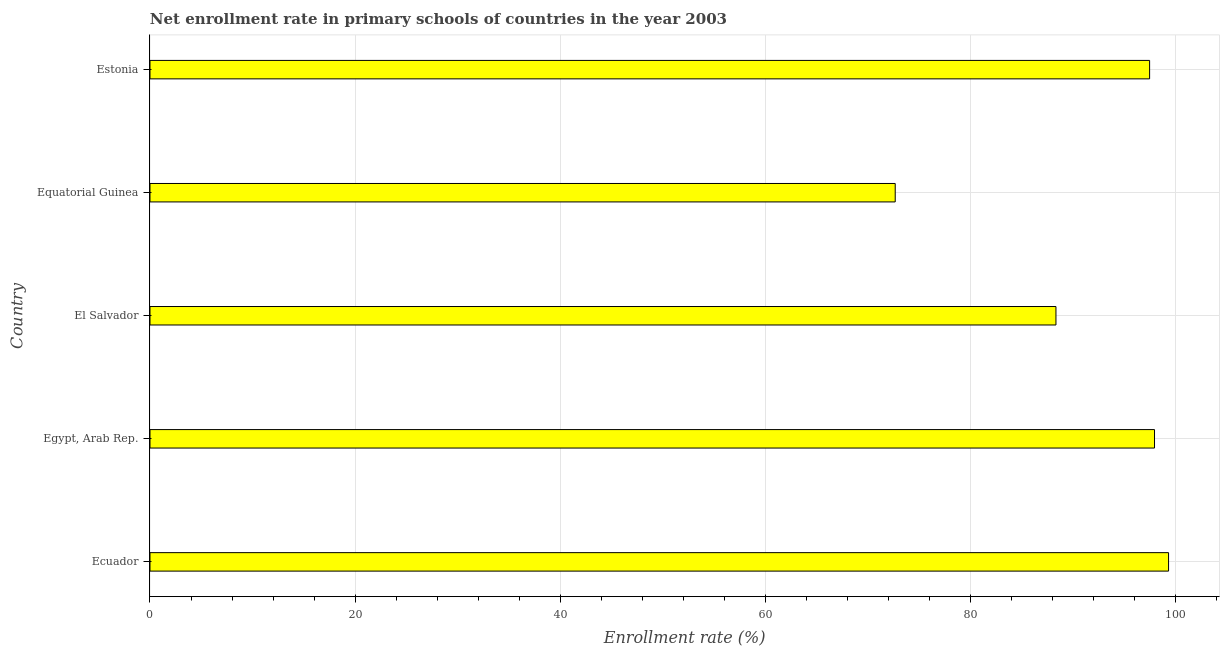Does the graph contain any zero values?
Provide a succinct answer. No. Does the graph contain grids?
Your response must be concise. Yes. What is the title of the graph?
Offer a very short reply. Net enrollment rate in primary schools of countries in the year 2003. What is the label or title of the X-axis?
Provide a short and direct response. Enrollment rate (%). What is the net enrollment rate in primary schools in Equatorial Guinea?
Provide a succinct answer. 72.68. Across all countries, what is the maximum net enrollment rate in primary schools?
Keep it short and to the point. 99.34. Across all countries, what is the minimum net enrollment rate in primary schools?
Ensure brevity in your answer.  72.68. In which country was the net enrollment rate in primary schools maximum?
Your answer should be very brief. Ecuador. In which country was the net enrollment rate in primary schools minimum?
Your response must be concise. Equatorial Guinea. What is the sum of the net enrollment rate in primary schools?
Offer a terse response. 455.85. What is the difference between the net enrollment rate in primary schools in El Salvador and Estonia?
Ensure brevity in your answer.  -9.13. What is the average net enrollment rate in primary schools per country?
Your response must be concise. 91.17. What is the median net enrollment rate in primary schools?
Offer a very short reply. 97.49. What is the ratio of the net enrollment rate in primary schools in Equatorial Guinea to that in Estonia?
Make the answer very short. 0.75. Is the difference between the net enrollment rate in primary schools in Ecuador and Egypt, Arab Rep. greater than the difference between any two countries?
Make the answer very short. No. What is the difference between the highest and the second highest net enrollment rate in primary schools?
Make the answer very short. 1.37. Is the sum of the net enrollment rate in primary schools in Ecuador and Equatorial Guinea greater than the maximum net enrollment rate in primary schools across all countries?
Make the answer very short. Yes. What is the difference between the highest and the lowest net enrollment rate in primary schools?
Offer a terse response. 26.66. Are all the bars in the graph horizontal?
Give a very brief answer. Yes. How many countries are there in the graph?
Your answer should be compact. 5. What is the difference between two consecutive major ticks on the X-axis?
Keep it short and to the point. 20. Are the values on the major ticks of X-axis written in scientific E-notation?
Offer a very short reply. No. What is the Enrollment rate (%) in Ecuador?
Your answer should be compact. 99.34. What is the Enrollment rate (%) of Egypt, Arab Rep.?
Provide a succinct answer. 97.97. What is the Enrollment rate (%) in El Salvador?
Your response must be concise. 88.36. What is the Enrollment rate (%) of Equatorial Guinea?
Provide a short and direct response. 72.68. What is the Enrollment rate (%) in Estonia?
Provide a short and direct response. 97.49. What is the difference between the Enrollment rate (%) in Ecuador and Egypt, Arab Rep.?
Keep it short and to the point. 1.37. What is the difference between the Enrollment rate (%) in Ecuador and El Salvador?
Provide a short and direct response. 10.98. What is the difference between the Enrollment rate (%) in Ecuador and Equatorial Guinea?
Give a very brief answer. 26.66. What is the difference between the Enrollment rate (%) in Ecuador and Estonia?
Provide a succinct answer. 1.85. What is the difference between the Enrollment rate (%) in Egypt, Arab Rep. and El Salvador?
Ensure brevity in your answer.  9.61. What is the difference between the Enrollment rate (%) in Egypt, Arab Rep. and Equatorial Guinea?
Your answer should be compact. 25.29. What is the difference between the Enrollment rate (%) in Egypt, Arab Rep. and Estonia?
Your response must be concise. 0.48. What is the difference between the Enrollment rate (%) in El Salvador and Equatorial Guinea?
Keep it short and to the point. 15.68. What is the difference between the Enrollment rate (%) in El Salvador and Estonia?
Offer a terse response. -9.13. What is the difference between the Enrollment rate (%) in Equatorial Guinea and Estonia?
Give a very brief answer. -24.81. What is the ratio of the Enrollment rate (%) in Ecuador to that in Egypt, Arab Rep.?
Offer a very short reply. 1.01. What is the ratio of the Enrollment rate (%) in Ecuador to that in El Salvador?
Offer a terse response. 1.12. What is the ratio of the Enrollment rate (%) in Ecuador to that in Equatorial Guinea?
Make the answer very short. 1.37. What is the ratio of the Enrollment rate (%) in Ecuador to that in Estonia?
Offer a very short reply. 1.02. What is the ratio of the Enrollment rate (%) in Egypt, Arab Rep. to that in El Salvador?
Provide a succinct answer. 1.11. What is the ratio of the Enrollment rate (%) in Egypt, Arab Rep. to that in Equatorial Guinea?
Make the answer very short. 1.35. What is the ratio of the Enrollment rate (%) in Egypt, Arab Rep. to that in Estonia?
Offer a very short reply. 1. What is the ratio of the Enrollment rate (%) in El Salvador to that in Equatorial Guinea?
Give a very brief answer. 1.22. What is the ratio of the Enrollment rate (%) in El Salvador to that in Estonia?
Give a very brief answer. 0.91. What is the ratio of the Enrollment rate (%) in Equatorial Guinea to that in Estonia?
Keep it short and to the point. 0.75. 